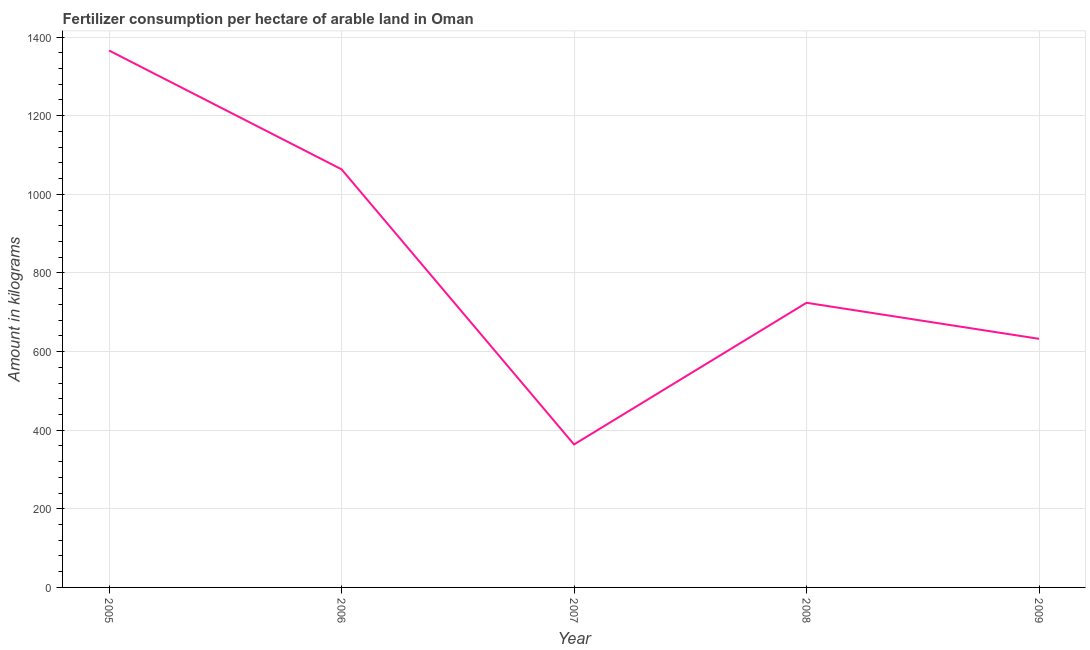What is the amount of fertilizer consumption in 2009?
Provide a succinct answer. 632.43. Across all years, what is the maximum amount of fertilizer consumption?
Give a very brief answer. 1365.82. Across all years, what is the minimum amount of fertilizer consumption?
Offer a terse response. 363.75. In which year was the amount of fertilizer consumption maximum?
Offer a very short reply. 2005. In which year was the amount of fertilizer consumption minimum?
Ensure brevity in your answer.  2007. What is the sum of the amount of fertilizer consumption?
Offer a terse response. 4149.72. What is the difference between the amount of fertilizer consumption in 2008 and 2009?
Offer a terse response. 91.67. What is the average amount of fertilizer consumption per year?
Your answer should be compact. 829.94. What is the median amount of fertilizer consumption?
Keep it short and to the point. 724.1. In how many years, is the amount of fertilizer consumption greater than 40 kg?
Keep it short and to the point. 5. What is the ratio of the amount of fertilizer consumption in 2008 to that in 2009?
Provide a short and direct response. 1.14. Is the amount of fertilizer consumption in 2005 less than that in 2007?
Provide a short and direct response. No. What is the difference between the highest and the second highest amount of fertilizer consumption?
Ensure brevity in your answer.  302.21. Is the sum of the amount of fertilizer consumption in 2006 and 2008 greater than the maximum amount of fertilizer consumption across all years?
Give a very brief answer. Yes. What is the difference between the highest and the lowest amount of fertilizer consumption?
Your answer should be compact. 1002.07. How many lines are there?
Provide a short and direct response. 1. What is the title of the graph?
Make the answer very short. Fertilizer consumption per hectare of arable land in Oman . What is the label or title of the Y-axis?
Keep it short and to the point. Amount in kilograms. What is the Amount in kilograms of 2005?
Provide a short and direct response. 1365.82. What is the Amount in kilograms of 2006?
Provide a succinct answer. 1063.62. What is the Amount in kilograms in 2007?
Your answer should be very brief. 363.75. What is the Amount in kilograms of 2008?
Make the answer very short. 724.1. What is the Amount in kilograms in 2009?
Your response must be concise. 632.43. What is the difference between the Amount in kilograms in 2005 and 2006?
Offer a very short reply. 302.21. What is the difference between the Amount in kilograms in 2005 and 2007?
Your response must be concise. 1002.07. What is the difference between the Amount in kilograms in 2005 and 2008?
Ensure brevity in your answer.  641.72. What is the difference between the Amount in kilograms in 2005 and 2009?
Give a very brief answer. 733.39. What is the difference between the Amount in kilograms in 2006 and 2007?
Keep it short and to the point. 699.87. What is the difference between the Amount in kilograms in 2006 and 2008?
Your answer should be compact. 339.52. What is the difference between the Amount in kilograms in 2006 and 2009?
Offer a very short reply. 431.18. What is the difference between the Amount in kilograms in 2007 and 2008?
Your response must be concise. -360.35. What is the difference between the Amount in kilograms in 2007 and 2009?
Your response must be concise. -268.68. What is the difference between the Amount in kilograms in 2008 and 2009?
Your answer should be very brief. 91.67. What is the ratio of the Amount in kilograms in 2005 to that in 2006?
Your answer should be compact. 1.28. What is the ratio of the Amount in kilograms in 2005 to that in 2007?
Offer a terse response. 3.75. What is the ratio of the Amount in kilograms in 2005 to that in 2008?
Offer a terse response. 1.89. What is the ratio of the Amount in kilograms in 2005 to that in 2009?
Your answer should be very brief. 2.16. What is the ratio of the Amount in kilograms in 2006 to that in 2007?
Offer a terse response. 2.92. What is the ratio of the Amount in kilograms in 2006 to that in 2008?
Keep it short and to the point. 1.47. What is the ratio of the Amount in kilograms in 2006 to that in 2009?
Your response must be concise. 1.68. What is the ratio of the Amount in kilograms in 2007 to that in 2008?
Give a very brief answer. 0.5. What is the ratio of the Amount in kilograms in 2007 to that in 2009?
Your response must be concise. 0.57. What is the ratio of the Amount in kilograms in 2008 to that in 2009?
Your answer should be very brief. 1.15. 